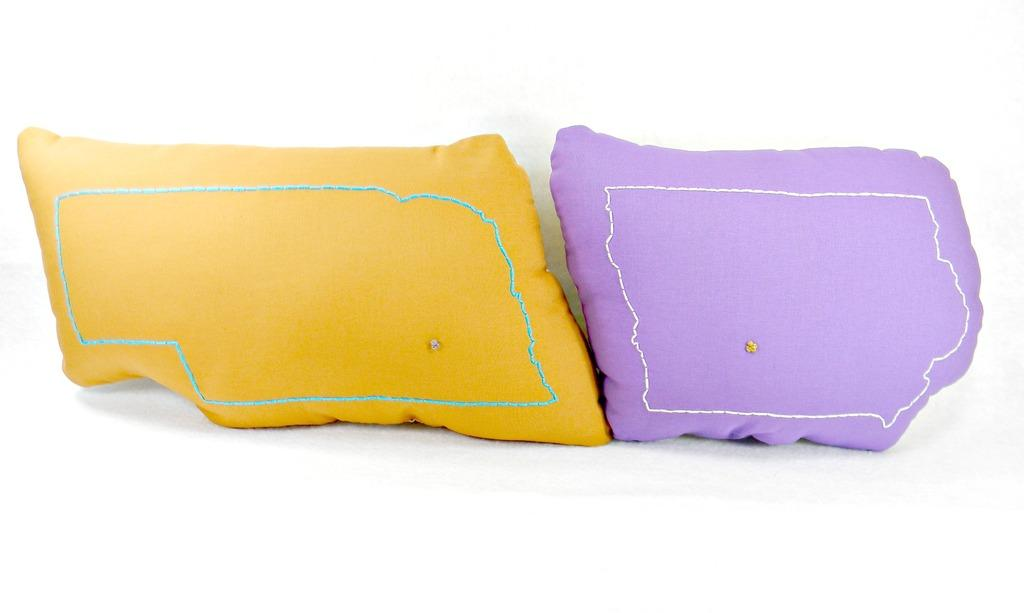How many pillows are visible in the image? There are two pillows in the image. What colors are the pillows? One pillow is yellow, and the other pillow is violet. What color is the background of the image? The background is white. What shape are the pillows in the image? The shape of the pillows cannot be determined from the image, as only their colors are mentioned. 